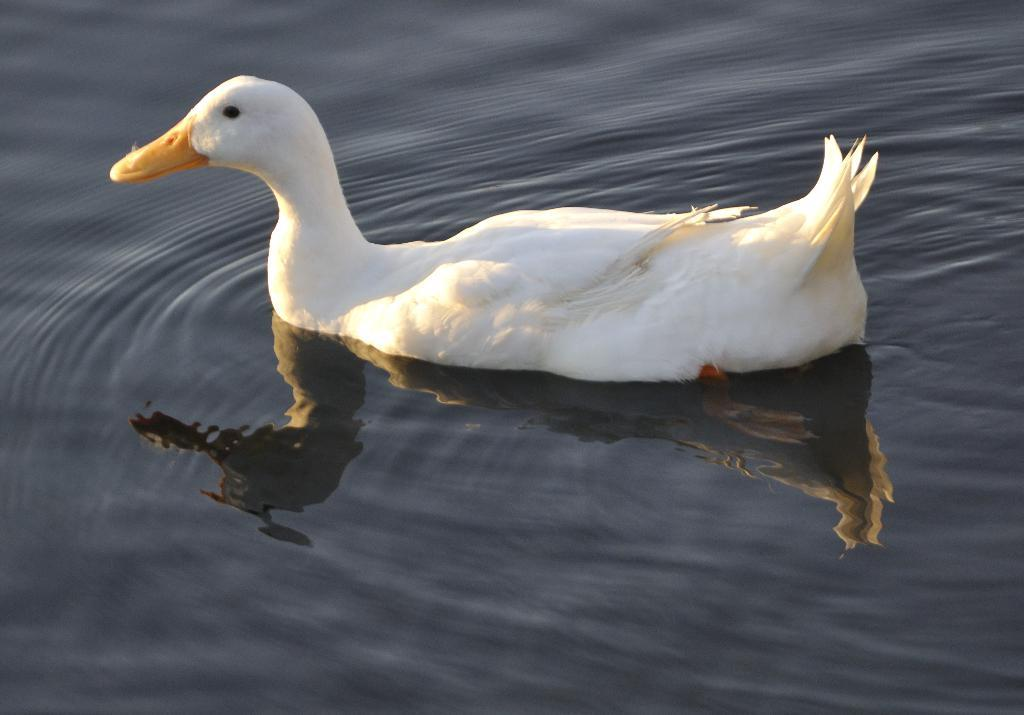What animal is present in the image? There is a duck in the image. Where is the duck located? The duck is on the water. What type of engine is powering the duck in the image? There is no engine present in the image, as the duck is a living animal and not a machine. 